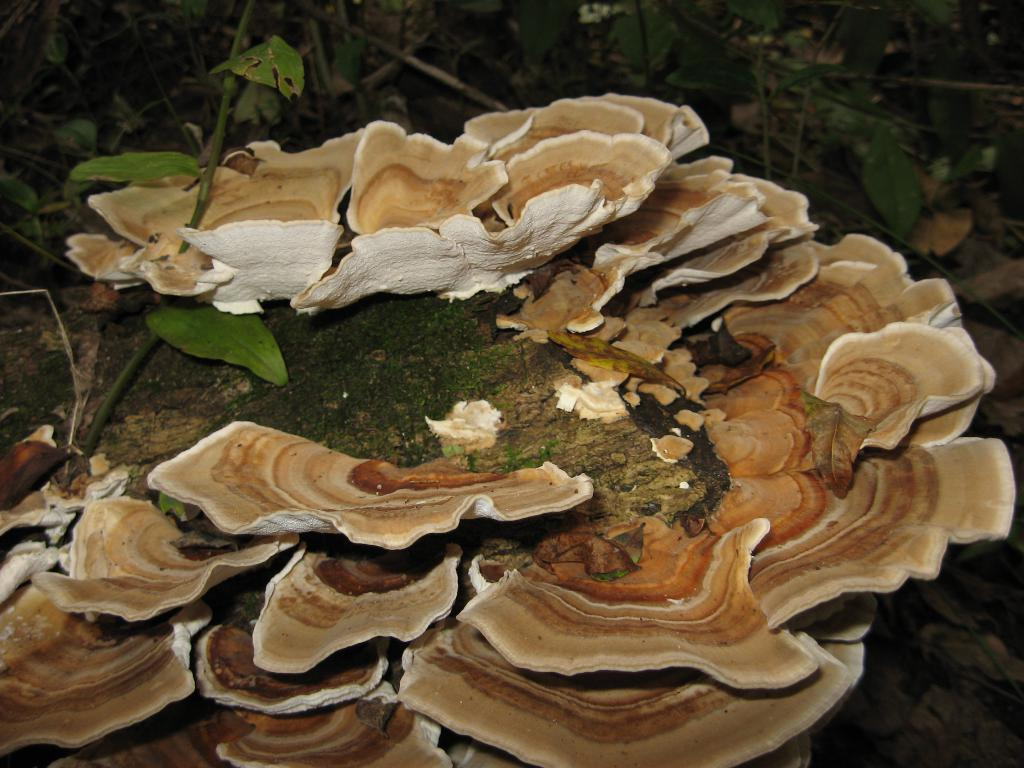What type of plant life is visible in the image? There are green leaves and stems in the image. What other natural elements can be seen in the image? There are hongos (mushrooms) in the image. What type of oil is being used to cook the mushrooms in the image? There is no oil or cooking activity present in the image; it features green leaves, stems, and mushrooms. Can you tell me the price of the mushrooms in the image? There is no receipt or pricing information present in the image; it simply shows green leaves, stems, and mushrooms. 